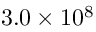<formula> <loc_0><loc_0><loc_500><loc_500>3 . 0 \times 1 0 ^ { 8 }</formula> 